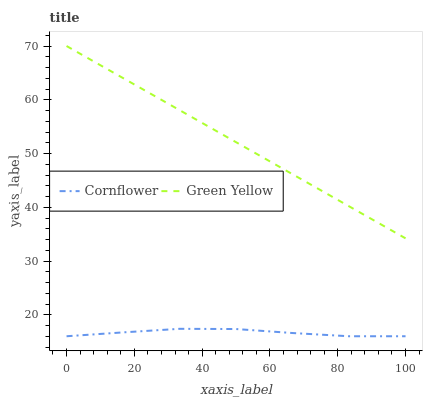Does Cornflower have the minimum area under the curve?
Answer yes or no. Yes. Does Green Yellow have the maximum area under the curve?
Answer yes or no. Yes. Does Green Yellow have the minimum area under the curve?
Answer yes or no. No. Is Green Yellow the smoothest?
Answer yes or no. Yes. Is Cornflower the roughest?
Answer yes or no. Yes. Is Green Yellow the roughest?
Answer yes or no. No. Does Cornflower have the lowest value?
Answer yes or no. Yes. Does Green Yellow have the lowest value?
Answer yes or no. No. Does Green Yellow have the highest value?
Answer yes or no. Yes. Is Cornflower less than Green Yellow?
Answer yes or no. Yes. Is Green Yellow greater than Cornflower?
Answer yes or no. Yes. Does Cornflower intersect Green Yellow?
Answer yes or no. No. 